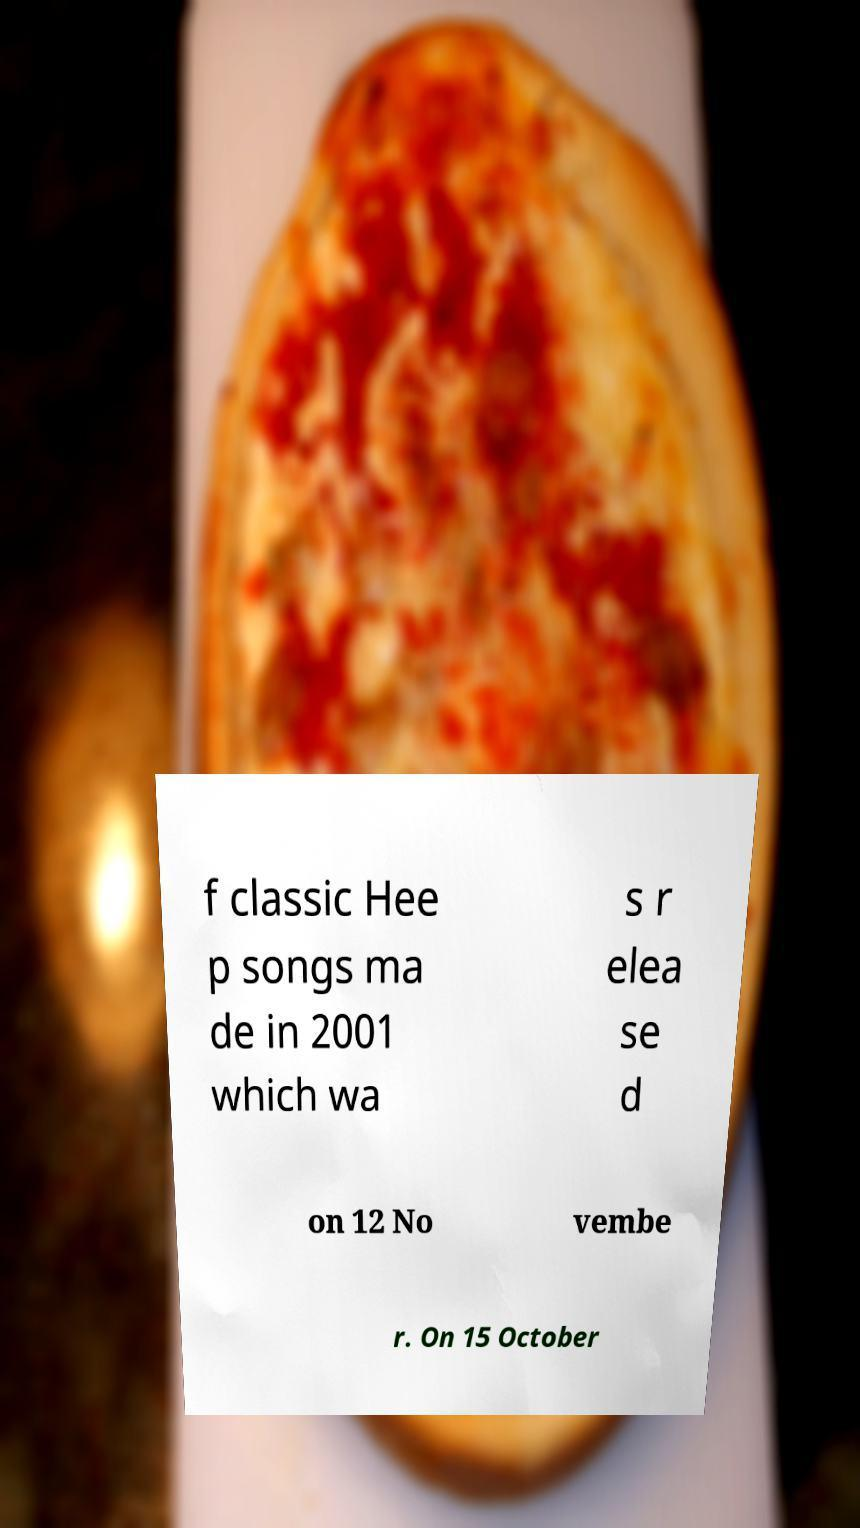Can you accurately transcribe the text from the provided image for me? f classic Hee p songs ma de in 2001 which wa s r elea se d on 12 No vembe r. On 15 October 